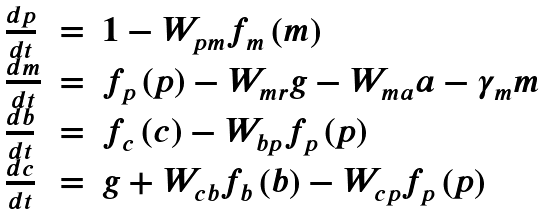Convert formula to latex. <formula><loc_0><loc_0><loc_500><loc_500>\begin{array} { l l l } \frac { d p } { d t } & = & 1 - W _ { p m } f _ { m } \left ( m \right ) \\ \frac { d m } { d t } & = & f _ { p } \left ( p \right ) - W _ { m r } g - W _ { m a } a - \gamma _ { m } m \\ \frac { d b } { d t } & = & f _ { c } \left ( c \right ) - W _ { b p } f _ { p } \left ( p \right ) \\ \frac { d c } { d t } & = & g + W _ { c b } f _ { b } \left ( b \right ) - W _ { c p } f _ { p } \left ( p \right ) \end{array}</formula> 